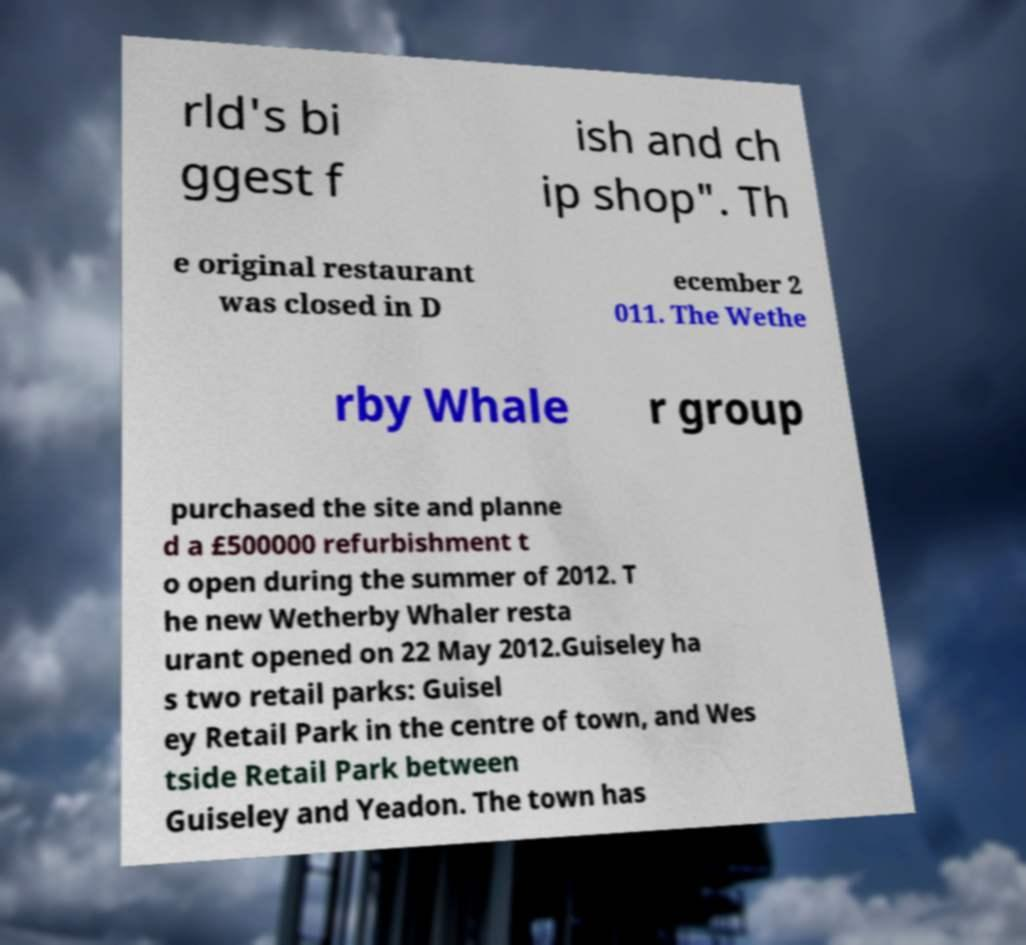Please identify and transcribe the text found in this image. rld's bi ggest f ish and ch ip shop". Th e original restaurant was closed in D ecember 2 011. The Wethe rby Whale r group purchased the site and planne d a £500000 refurbishment t o open during the summer of 2012. T he new Wetherby Whaler resta urant opened on 22 May 2012.Guiseley ha s two retail parks: Guisel ey Retail Park in the centre of town, and Wes tside Retail Park between Guiseley and Yeadon. The town has 